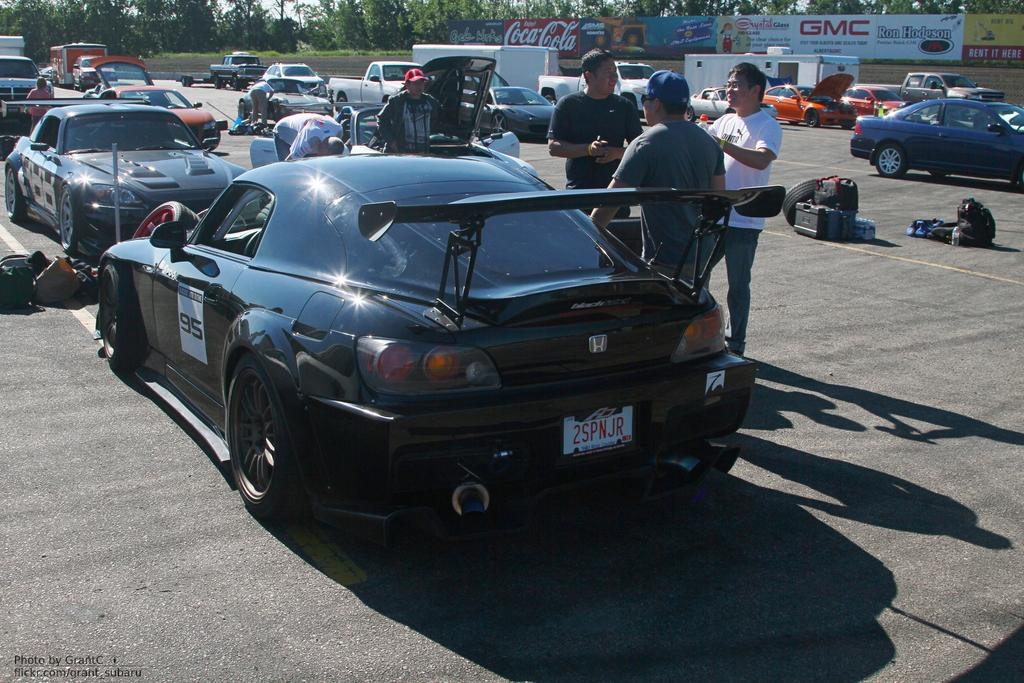What type of vehicles can be seen in the image? There are cars in the image. What else is present in the image besides cars? There are people standing in the image. What type of vegetation is visible in the image? There are green trees in the image. What is the plot of the story being told in the image? There is no story being told in the image, as it is a static representation of cars, people, and trees. 